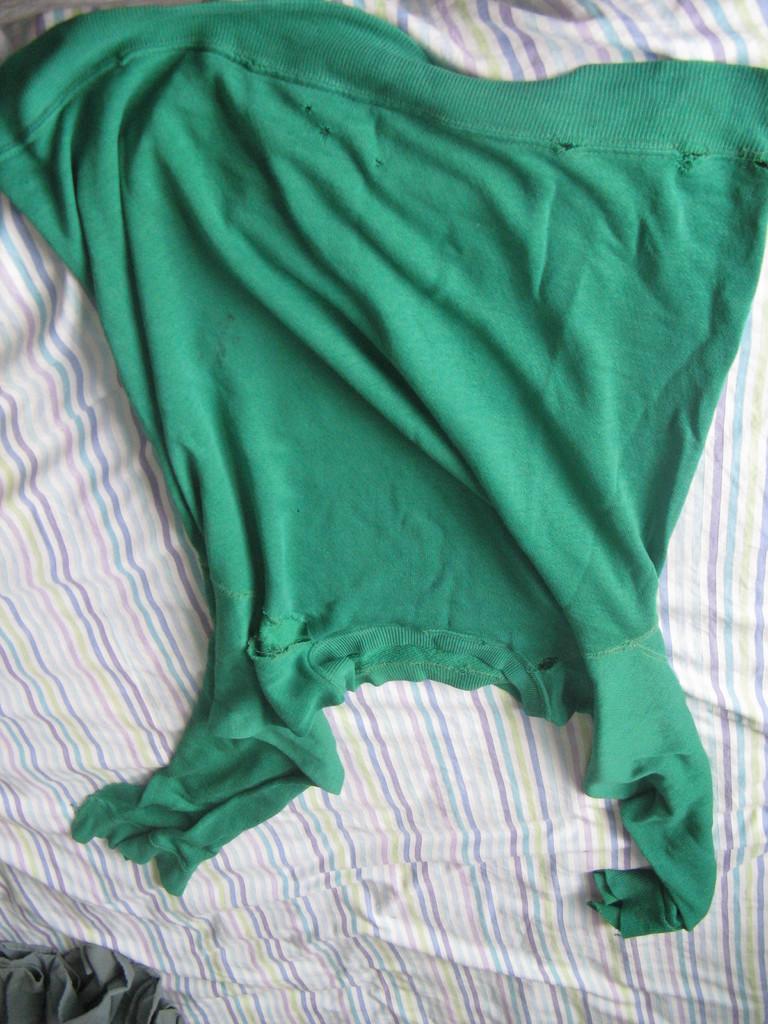Describe this image in one or two sentences. In this image, we can see a cloth on the bed sheet. 